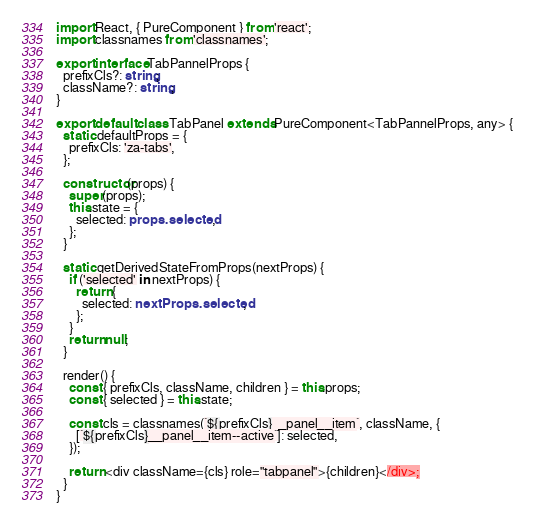<code> <loc_0><loc_0><loc_500><loc_500><_TypeScript_>import React, { PureComponent } from 'react';
import classnames from 'classnames';

export interface TabPannelProps {
  prefixCls?: string;
  className?: string;
}

export default class TabPanel extends PureComponent<TabPannelProps, any> {
  static defaultProps = {
    prefixCls: 'za-tabs',
  };

  constructor(props) {
    super(props);
    this.state = {
      selected: props.selected,
    };
  }

  static getDerivedStateFromProps(nextProps) {
    if ('selected' in nextProps) {
      return {
        selected: nextProps.selected,
      };
    }
    return null;
  }

  render() {
    const { prefixCls, className, children } = this.props;
    const { selected } = this.state;

    const cls = classnames(`${prefixCls}__panel__item`, className, {
      [`${prefixCls}__panel__item--active`]: selected,
    });

    return <div className={cls} role="tabpanel">{children}</div>;
  }
}
</code> 